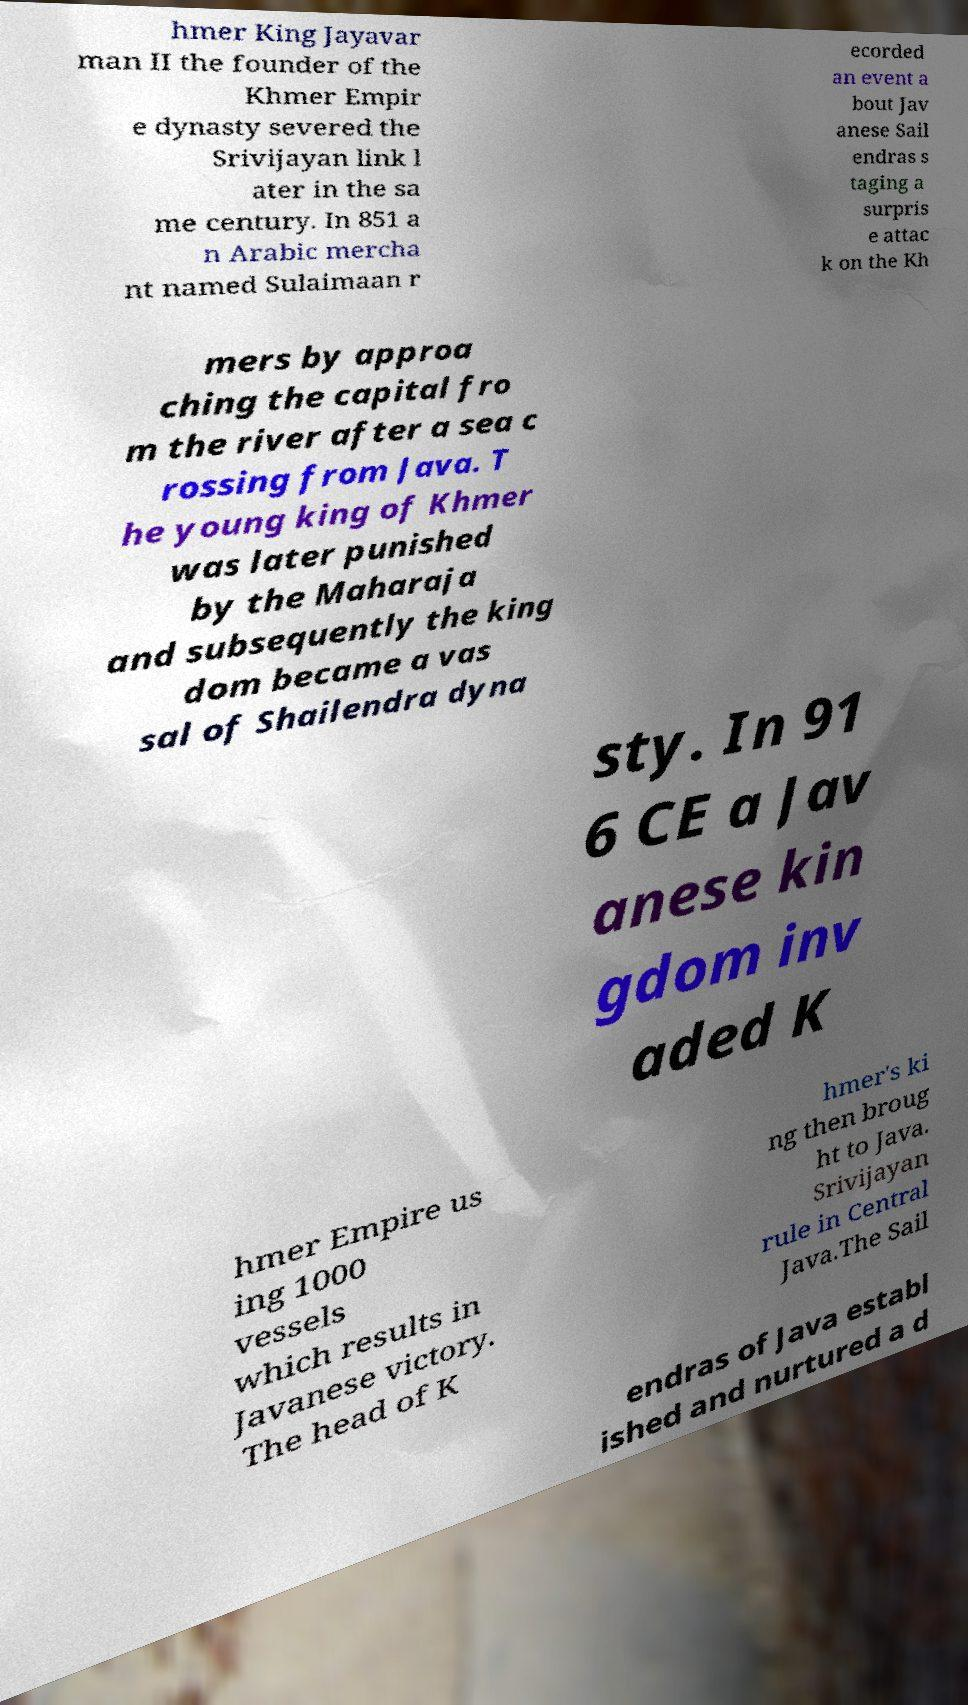For documentation purposes, I need the text within this image transcribed. Could you provide that? hmer King Jayavar man II the founder of the Khmer Empir e dynasty severed the Srivijayan link l ater in the sa me century. In 851 a n Arabic mercha nt named Sulaimaan r ecorded an event a bout Jav anese Sail endras s taging a surpris e attac k on the Kh mers by approa ching the capital fro m the river after a sea c rossing from Java. T he young king of Khmer was later punished by the Maharaja and subsequently the king dom became a vas sal of Shailendra dyna sty. In 91 6 CE a Jav anese kin gdom inv aded K hmer Empire us ing 1000 vessels which results in Javanese victory. The head of K hmer's ki ng then broug ht to Java. Srivijayan rule in Central Java.The Sail endras of Java establ ished and nurtured a d 